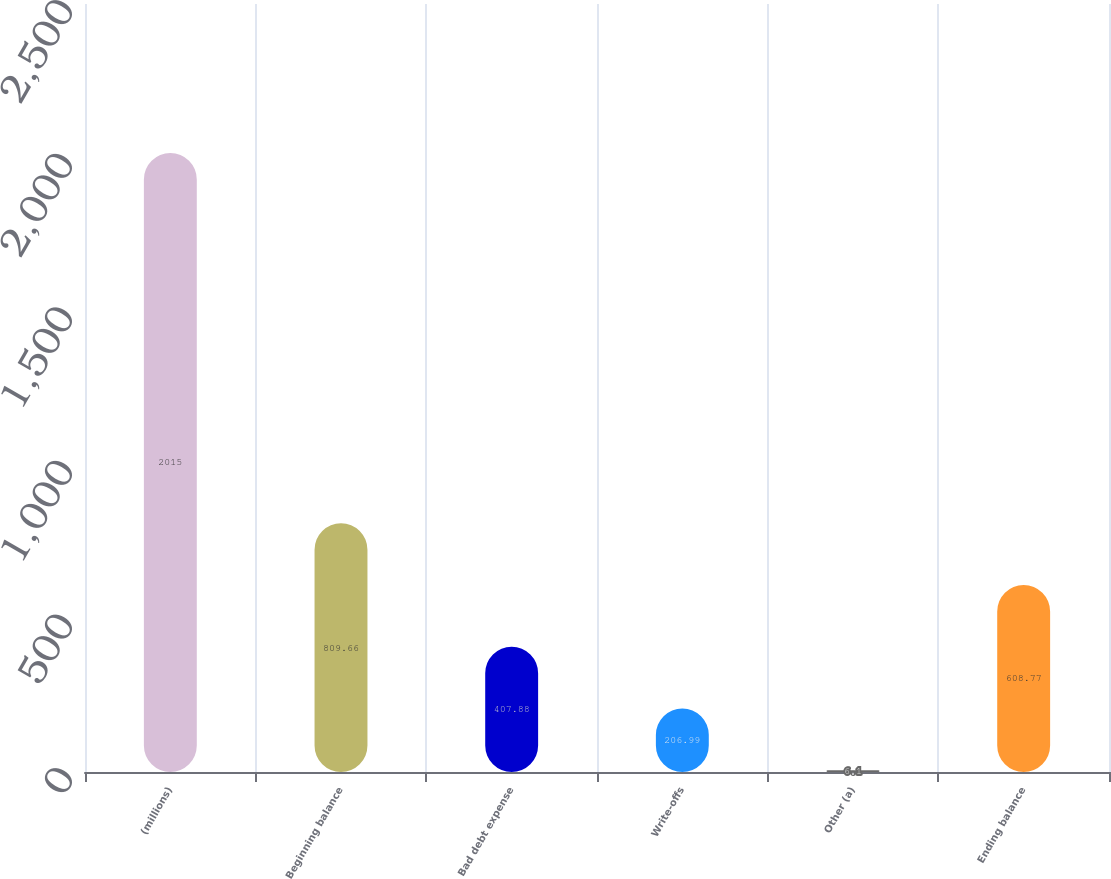Convert chart to OTSL. <chart><loc_0><loc_0><loc_500><loc_500><bar_chart><fcel>(millions)<fcel>Beginning balance<fcel>Bad debt expense<fcel>Write-offs<fcel>Other (a)<fcel>Ending balance<nl><fcel>2015<fcel>809.66<fcel>407.88<fcel>206.99<fcel>6.1<fcel>608.77<nl></chart> 